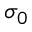<formula> <loc_0><loc_0><loc_500><loc_500>\sigma _ { 0 }</formula> 